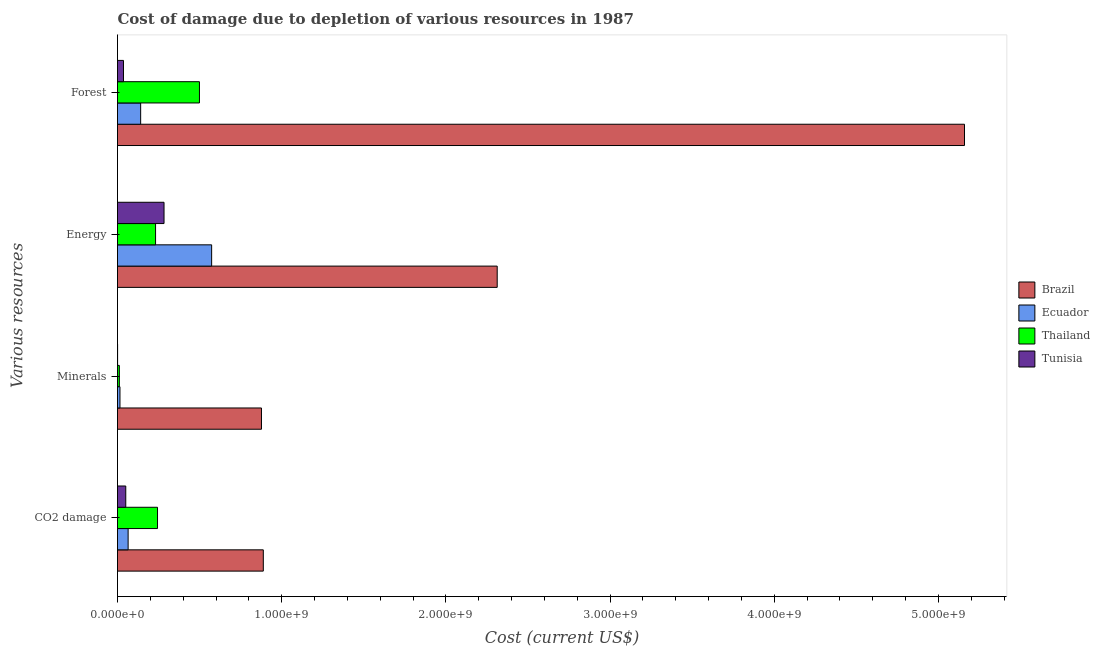How many different coloured bars are there?
Keep it short and to the point. 4. How many groups of bars are there?
Give a very brief answer. 4. Are the number of bars on each tick of the Y-axis equal?
Ensure brevity in your answer.  Yes. What is the label of the 1st group of bars from the top?
Offer a very short reply. Forest. What is the cost of damage due to depletion of forests in Tunisia?
Offer a terse response. 3.64e+07. Across all countries, what is the maximum cost of damage due to depletion of energy?
Provide a short and direct response. 2.31e+09. Across all countries, what is the minimum cost of damage due to depletion of coal?
Offer a terse response. 5.03e+07. In which country was the cost of damage due to depletion of minerals minimum?
Your answer should be very brief. Tunisia. What is the total cost of damage due to depletion of coal in the graph?
Offer a terse response. 1.25e+09. What is the difference between the cost of damage due to depletion of coal in Thailand and that in Ecuador?
Keep it short and to the point. 1.79e+08. What is the difference between the cost of damage due to depletion of forests in Brazil and the cost of damage due to depletion of minerals in Ecuador?
Keep it short and to the point. 5.14e+09. What is the average cost of damage due to depletion of energy per country?
Provide a short and direct response. 8.50e+08. What is the difference between the cost of damage due to depletion of energy and cost of damage due to depletion of forests in Tunisia?
Make the answer very short. 2.47e+08. What is the ratio of the cost of damage due to depletion of coal in Ecuador to that in Thailand?
Give a very brief answer. 0.27. What is the difference between the highest and the second highest cost of damage due to depletion of minerals?
Give a very brief answer. 8.62e+08. What is the difference between the highest and the lowest cost of damage due to depletion of coal?
Your response must be concise. 8.38e+08. Is it the case that in every country, the sum of the cost of damage due to depletion of forests and cost of damage due to depletion of coal is greater than the sum of cost of damage due to depletion of minerals and cost of damage due to depletion of energy?
Ensure brevity in your answer.  Yes. What does the 2nd bar from the top in Forest represents?
Your answer should be very brief. Thailand. What does the 3rd bar from the bottom in CO2 damage represents?
Provide a short and direct response. Thailand. Are all the bars in the graph horizontal?
Offer a terse response. Yes. How many countries are there in the graph?
Keep it short and to the point. 4. Are the values on the major ticks of X-axis written in scientific E-notation?
Offer a very short reply. Yes. What is the title of the graph?
Offer a very short reply. Cost of damage due to depletion of various resources in 1987 . Does "Kazakhstan" appear as one of the legend labels in the graph?
Ensure brevity in your answer.  No. What is the label or title of the X-axis?
Your response must be concise. Cost (current US$). What is the label or title of the Y-axis?
Give a very brief answer. Various resources. What is the Cost (current US$) of Brazil in CO2 damage?
Offer a very short reply. 8.88e+08. What is the Cost (current US$) of Ecuador in CO2 damage?
Give a very brief answer. 6.47e+07. What is the Cost (current US$) in Thailand in CO2 damage?
Ensure brevity in your answer.  2.44e+08. What is the Cost (current US$) in Tunisia in CO2 damage?
Provide a succinct answer. 5.03e+07. What is the Cost (current US$) of Brazil in Minerals?
Make the answer very short. 8.77e+08. What is the Cost (current US$) of Ecuador in Minerals?
Your response must be concise. 1.50e+07. What is the Cost (current US$) of Thailand in Minerals?
Keep it short and to the point. 1.12e+07. What is the Cost (current US$) in Tunisia in Minerals?
Provide a short and direct response. 5.67e+05. What is the Cost (current US$) of Brazil in Energy?
Your answer should be compact. 2.31e+09. What is the Cost (current US$) in Ecuador in Energy?
Ensure brevity in your answer.  5.73e+08. What is the Cost (current US$) of Thailand in Energy?
Keep it short and to the point. 2.32e+08. What is the Cost (current US$) of Tunisia in Energy?
Ensure brevity in your answer.  2.83e+08. What is the Cost (current US$) in Brazil in Forest?
Give a very brief answer. 5.16e+09. What is the Cost (current US$) of Ecuador in Forest?
Provide a succinct answer. 1.41e+08. What is the Cost (current US$) in Thailand in Forest?
Provide a succinct answer. 4.99e+08. What is the Cost (current US$) of Tunisia in Forest?
Your response must be concise. 3.64e+07. Across all Various resources, what is the maximum Cost (current US$) in Brazil?
Keep it short and to the point. 5.16e+09. Across all Various resources, what is the maximum Cost (current US$) in Ecuador?
Provide a succinct answer. 5.73e+08. Across all Various resources, what is the maximum Cost (current US$) in Thailand?
Make the answer very short. 4.99e+08. Across all Various resources, what is the maximum Cost (current US$) in Tunisia?
Provide a succinct answer. 2.83e+08. Across all Various resources, what is the minimum Cost (current US$) of Brazil?
Your answer should be very brief. 8.77e+08. Across all Various resources, what is the minimum Cost (current US$) of Ecuador?
Your answer should be very brief. 1.50e+07. Across all Various resources, what is the minimum Cost (current US$) in Thailand?
Your answer should be very brief. 1.12e+07. Across all Various resources, what is the minimum Cost (current US$) of Tunisia?
Provide a succinct answer. 5.67e+05. What is the total Cost (current US$) in Brazil in the graph?
Your response must be concise. 9.24e+09. What is the total Cost (current US$) of Ecuador in the graph?
Keep it short and to the point. 7.94e+08. What is the total Cost (current US$) in Thailand in the graph?
Keep it short and to the point. 9.86e+08. What is the total Cost (current US$) of Tunisia in the graph?
Your answer should be very brief. 3.71e+08. What is the difference between the Cost (current US$) in Brazil in CO2 damage and that in Minerals?
Your response must be concise. 1.12e+07. What is the difference between the Cost (current US$) in Ecuador in CO2 damage and that in Minerals?
Your answer should be very brief. 4.96e+07. What is the difference between the Cost (current US$) in Thailand in CO2 damage and that in Minerals?
Offer a terse response. 2.33e+08. What is the difference between the Cost (current US$) in Tunisia in CO2 damage and that in Minerals?
Make the answer very short. 4.97e+07. What is the difference between the Cost (current US$) in Brazil in CO2 damage and that in Energy?
Offer a terse response. -1.42e+09. What is the difference between the Cost (current US$) in Ecuador in CO2 damage and that in Energy?
Keep it short and to the point. -5.09e+08. What is the difference between the Cost (current US$) in Thailand in CO2 damage and that in Energy?
Offer a very short reply. 1.18e+07. What is the difference between the Cost (current US$) in Tunisia in CO2 damage and that in Energy?
Give a very brief answer. -2.33e+08. What is the difference between the Cost (current US$) of Brazil in CO2 damage and that in Forest?
Offer a very short reply. -4.27e+09. What is the difference between the Cost (current US$) in Ecuador in CO2 damage and that in Forest?
Provide a short and direct response. -7.63e+07. What is the difference between the Cost (current US$) of Thailand in CO2 damage and that in Forest?
Provide a short and direct response. -2.55e+08. What is the difference between the Cost (current US$) of Tunisia in CO2 damage and that in Forest?
Your answer should be compact. 1.39e+07. What is the difference between the Cost (current US$) of Brazil in Minerals and that in Energy?
Keep it short and to the point. -1.44e+09. What is the difference between the Cost (current US$) of Ecuador in Minerals and that in Energy?
Make the answer very short. -5.58e+08. What is the difference between the Cost (current US$) of Thailand in Minerals and that in Energy?
Ensure brevity in your answer.  -2.21e+08. What is the difference between the Cost (current US$) of Tunisia in Minerals and that in Energy?
Give a very brief answer. -2.83e+08. What is the difference between the Cost (current US$) of Brazil in Minerals and that in Forest?
Provide a succinct answer. -4.28e+09. What is the difference between the Cost (current US$) of Ecuador in Minerals and that in Forest?
Offer a very short reply. -1.26e+08. What is the difference between the Cost (current US$) of Thailand in Minerals and that in Forest?
Offer a terse response. -4.88e+08. What is the difference between the Cost (current US$) in Tunisia in Minerals and that in Forest?
Your answer should be very brief. -3.58e+07. What is the difference between the Cost (current US$) in Brazil in Energy and that in Forest?
Ensure brevity in your answer.  -2.85e+09. What is the difference between the Cost (current US$) of Ecuador in Energy and that in Forest?
Offer a terse response. 4.32e+08. What is the difference between the Cost (current US$) in Thailand in Energy and that in Forest?
Provide a short and direct response. -2.67e+08. What is the difference between the Cost (current US$) of Tunisia in Energy and that in Forest?
Give a very brief answer. 2.47e+08. What is the difference between the Cost (current US$) in Brazil in CO2 damage and the Cost (current US$) in Ecuador in Minerals?
Offer a very short reply. 8.73e+08. What is the difference between the Cost (current US$) in Brazil in CO2 damage and the Cost (current US$) in Thailand in Minerals?
Ensure brevity in your answer.  8.77e+08. What is the difference between the Cost (current US$) of Brazil in CO2 damage and the Cost (current US$) of Tunisia in Minerals?
Offer a terse response. 8.87e+08. What is the difference between the Cost (current US$) of Ecuador in CO2 damage and the Cost (current US$) of Thailand in Minerals?
Provide a succinct answer. 5.35e+07. What is the difference between the Cost (current US$) in Ecuador in CO2 damage and the Cost (current US$) in Tunisia in Minerals?
Give a very brief answer. 6.41e+07. What is the difference between the Cost (current US$) in Thailand in CO2 damage and the Cost (current US$) in Tunisia in Minerals?
Make the answer very short. 2.43e+08. What is the difference between the Cost (current US$) in Brazil in CO2 damage and the Cost (current US$) in Ecuador in Energy?
Your answer should be compact. 3.15e+08. What is the difference between the Cost (current US$) in Brazil in CO2 damage and the Cost (current US$) in Thailand in Energy?
Give a very brief answer. 6.56e+08. What is the difference between the Cost (current US$) in Brazil in CO2 damage and the Cost (current US$) in Tunisia in Energy?
Give a very brief answer. 6.05e+08. What is the difference between the Cost (current US$) in Ecuador in CO2 damage and the Cost (current US$) in Thailand in Energy?
Provide a succinct answer. -1.67e+08. What is the difference between the Cost (current US$) in Ecuador in CO2 damage and the Cost (current US$) in Tunisia in Energy?
Provide a succinct answer. -2.19e+08. What is the difference between the Cost (current US$) of Thailand in CO2 damage and the Cost (current US$) of Tunisia in Energy?
Give a very brief answer. -3.97e+07. What is the difference between the Cost (current US$) in Brazil in CO2 damage and the Cost (current US$) in Ecuador in Forest?
Provide a succinct answer. 7.47e+08. What is the difference between the Cost (current US$) of Brazil in CO2 damage and the Cost (current US$) of Thailand in Forest?
Give a very brief answer. 3.89e+08. What is the difference between the Cost (current US$) of Brazil in CO2 damage and the Cost (current US$) of Tunisia in Forest?
Offer a terse response. 8.52e+08. What is the difference between the Cost (current US$) of Ecuador in CO2 damage and the Cost (current US$) of Thailand in Forest?
Make the answer very short. -4.34e+08. What is the difference between the Cost (current US$) of Ecuador in CO2 damage and the Cost (current US$) of Tunisia in Forest?
Your response must be concise. 2.83e+07. What is the difference between the Cost (current US$) of Thailand in CO2 damage and the Cost (current US$) of Tunisia in Forest?
Make the answer very short. 2.07e+08. What is the difference between the Cost (current US$) of Brazil in Minerals and the Cost (current US$) of Ecuador in Energy?
Provide a succinct answer. 3.03e+08. What is the difference between the Cost (current US$) of Brazil in Minerals and the Cost (current US$) of Thailand in Energy?
Provide a short and direct response. 6.45e+08. What is the difference between the Cost (current US$) of Brazil in Minerals and the Cost (current US$) of Tunisia in Energy?
Your answer should be very brief. 5.93e+08. What is the difference between the Cost (current US$) in Ecuador in Minerals and the Cost (current US$) in Thailand in Energy?
Offer a very short reply. -2.17e+08. What is the difference between the Cost (current US$) in Ecuador in Minerals and the Cost (current US$) in Tunisia in Energy?
Provide a short and direct response. -2.68e+08. What is the difference between the Cost (current US$) of Thailand in Minerals and the Cost (current US$) of Tunisia in Energy?
Your response must be concise. -2.72e+08. What is the difference between the Cost (current US$) of Brazil in Minerals and the Cost (current US$) of Ecuador in Forest?
Make the answer very short. 7.36e+08. What is the difference between the Cost (current US$) of Brazil in Minerals and the Cost (current US$) of Thailand in Forest?
Keep it short and to the point. 3.78e+08. What is the difference between the Cost (current US$) of Brazil in Minerals and the Cost (current US$) of Tunisia in Forest?
Your answer should be very brief. 8.40e+08. What is the difference between the Cost (current US$) of Ecuador in Minerals and the Cost (current US$) of Thailand in Forest?
Your answer should be very brief. -4.84e+08. What is the difference between the Cost (current US$) of Ecuador in Minerals and the Cost (current US$) of Tunisia in Forest?
Offer a very short reply. -2.13e+07. What is the difference between the Cost (current US$) of Thailand in Minerals and the Cost (current US$) of Tunisia in Forest?
Make the answer very short. -2.52e+07. What is the difference between the Cost (current US$) of Brazil in Energy and the Cost (current US$) of Ecuador in Forest?
Give a very brief answer. 2.17e+09. What is the difference between the Cost (current US$) of Brazil in Energy and the Cost (current US$) of Thailand in Forest?
Give a very brief answer. 1.81e+09. What is the difference between the Cost (current US$) of Brazil in Energy and the Cost (current US$) of Tunisia in Forest?
Your answer should be very brief. 2.28e+09. What is the difference between the Cost (current US$) of Ecuador in Energy and the Cost (current US$) of Thailand in Forest?
Ensure brevity in your answer.  7.42e+07. What is the difference between the Cost (current US$) in Ecuador in Energy and the Cost (current US$) in Tunisia in Forest?
Provide a short and direct response. 5.37e+08. What is the difference between the Cost (current US$) in Thailand in Energy and the Cost (current US$) in Tunisia in Forest?
Provide a short and direct response. 1.95e+08. What is the average Cost (current US$) in Brazil per Various resources?
Offer a very short reply. 2.31e+09. What is the average Cost (current US$) in Ecuador per Various resources?
Give a very brief answer. 1.99e+08. What is the average Cost (current US$) in Thailand per Various resources?
Your answer should be compact. 2.46e+08. What is the average Cost (current US$) in Tunisia per Various resources?
Keep it short and to the point. 9.26e+07. What is the difference between the Cost (current US$) in Brazil and Cost (current US$) in Ecuador in CO2 damage?
Give a very brief answer. 8.23e+08. What is the difference between the Cost (current US$) in Brazil and Cost (current US$) in Thailand in CO2 damage?
Keep it short and to the point. 6.44e+08. What is the difference between the Cost (current US$) of Brazil and Cost (current US$) of Tunisia in CO2 damage?
Offer a terse response. 8.38e+08. What is the difference between the Cost (current US$) in Ecuador and Cost (current US$) in Thailand in CO2 damage?
Offer a terse response. -1.79e+08. What is the difference between the Cost (current US$) in Ecuador and Cost (current US$) in Tunisia in CO2 damage?
Make the answer very short. 1.44e+07. What is the difference between the Cost (current US$) of Thailand and Cost (current US$) of Tunisia in CO2 damage?
Offer a very short reply. 1.93e+08. What is the difference between the Cost (current US$) in Brazil and Cost (current US$) in Ecuador in Minerals?
Offer a terse response. 8.62e+08. What is the difference between the Cost (current US$) of Brazil and Cost (current US$) of Thailand in Minerals?
Offer a very short reply. 8.66e+08. What is the difference between the Cost (current US$) of Brazil and Cost (current US$) of Tunisia in Minerals?
Make the answer very short. 8.76e+08. What is the difference between the Cost (current US$) of Ecuador and Cost (current US$) of Thailand in Minerals?
Offer a terse response. 3.88e+06. What is the difference between the Cost (current US$) of Ecuador and Cost (current US$) of Tunisia in Minerals?
Provide a succinct answer. 1.45e+07. What is the difference between the Cost (current US$) of Thailand and Cost (current US$) of Tunisia in Minerals?
Your answer should be compact. 1.06e+07. What is the difference between the Cost (current US$) of Brazil and Cost (current US$) of Ecuador in Energy?
Your answer should be compact. 1.74e+09. What is the difference between the Cost (current US$) of Brazil and Cost (current US$) of Thailand in Energy?
Give a very brief answer. 2.08e+09. What is the difference between the Cost (current US$) in Brazil and Cost (current US$) in Tunisia in Energy?
Your answer should be compact. 2.03e+09. What is the difference between the Cost (current US$) in Ecuador and Cost (current US$) in Thailand in Energy?
Provide a short and direct response. 3.41e+08. What is the difference between the Cost (current US$) in Ecuador and Cost (current US$) in Tunisia in Energy?
Provide a short and direct response. 2.90e+08. What is the difference between the Cost (current US$) in Thailand and Cost (current US$) in Tunisia in Energy?
Provide a short and direct response. -5.15e+07. What is the difference between the Cost (current US$) in Brazil and Cost (current US$) in Ecuador in Forest?
Offer a very short reply. 5.02e+09. What is the difference between the Cost (current US$) of Brazil and Cost (current US$) of Thailand in Forest?
Provide a succinct answer. 4.66e+09. What is the difference between the Cost (current US$) of Brazil and Cost (current US$) of Tunisia in Forest?
Offer a terse response. 5.12e+09. What is the difference between the Cost (current US$) of Ecuador and Cost (current US$) of Thailand in Forest?
Ensure brevity in your answer.  -3.58e+08. What is the difference between the Cost (current US$) of Ecuador and Cost (current US$) of Tunisia in Forest?
Your answer should be very brief. 1.05e+08. What is the difference between the Cost (current US$) in Thailand and Cost (current US$) in Tunisia in Forest?
Offer a very short reply. 4.63e+08. What is the ratio of the Cost (current US$) of Brazil in CO2 damage to that in Minerals?
Provide a short and direct response. 1.01. What is the ratio of the Cost (current US$) in Ecuador in CO2 damage to that in Minerals?
Provide a short and direct response. 4.3. What is the ratio of the Cost (current US$) of Thailand in CO2 damage to that in Minerals?
Offer a very short reply. 21.85. What is the ratio of the Cost (current US$) of Tunisia in CO2 damage to that in Minerals?
Make the answer very short. 88.62. What is the ratio of the Cost (current US$) in Brazil in CO2 damage to that in Energy?
Give a very brief answer. 0.38. What is the ratio of the Cost (current US$) in Ecuador in CO2 damage to that in Energy?
Make the answer very short. 0.11. What is the ratio of the Cost (current US$) of Thailand in CO2 damage to that in Energy?
Make the answer very short. 1.05. What is the ratio of the Cost (current US$) in Tunisia in CO2 damage to that in Energy?
Make the answer very short. 0.18. What is the ratio of the Cost (current US$) of Brazil in CO2 damage to that in Forest?
Provide a succinct answer. 0.17. What is the ratio of the Cost (current US$) in Ecuador in CO2 damage to that in Forest?
Your response must be concise. 0.46. What is the ratio of the Cost (current US$) in Thailand in CO2 damage to that in Forest?
Ensure brevity in your answer.  0.49. What is the ratio of the Cost (current US$) of Tunisia in CO2 damage to that in Forest?
Provide a succinct answer. 1.38. What is the ratio of the Cost (current US$) in Brazil in Minerals to that in Energy?
Your response must be concise. 0.38. What is the ratio of the Cost (current US$) of Ecuador in Minerals to that in Energy?
Offer a terse response. 0.03. What is the ratio of the Cost (current US$) in Thailand in Minerals to that in Energy?
Your answer should be compact. 0.05. What is the ratio of the Cost (current US$) in Tunisia in Minerals to that in Energy?
Your answer should be very brief. 0. What is the ratio of the Cost (current US$) of Brazil in Minerals to that in Forest?
Provide a short and direct response. 0.17. What is the ratio of the Cost (current US$) in Ecuador in Minerals to that in Forest?
Ensure brevity in your answer.  0.11. What is the ratio of the Cost (current US$) in Thailand in Minerals to that in Forest?
Provide a short and direct response. 0.02. What is the ratio of the Cost (current US$) of Tunisia in Minerals to that in Forest?
Provide a succinct answer. 0.02. What is the ratio of the Cost (current US$) of Brazil in Energy to that in Forest?
Provide a succinct answer. 0.45. What is the ratio of the Cost (current US$) of Ecuador in Energy to that in Forest?
Your answer should be compact. 4.07. What is the ratio of the Cost (current US$) of Thailand in Energy to that in Forest?
Offer a very short reply. 0.46. What is the ratio of the Cost (current US$) of Tunisia in Energy to that in Forest?
Provide a short and direct response. 7.79. What is the difference between the highest and the second highest Cost (current US$) in Brazil?
Offer a very short reply. 2.85e+09. What is the difference between the highest and the second highest Cost (current US$) in Ecuador?
Provide a succinct answer. 4.32e+08. What is the difference between the highest and the second highest Cost (current US$) of Thailand?
Provide a succinct answer. 2.55e+08. What is the difference between the highest and the second highest Cost (current US$) in Tunisia?
Offer a terse response. 2.33e+08. What is the difference between the highest and the lowest Cost (current US$) of Brazil?
Offer a very short reply. 4.28e+09. What is the difference between the highest and the lowest Cost (current US$) in Ecuador?
Offer a terse response. 5.58e+08. What is the difference between the highest and the lowest Cost (current US$) in Thailand?
Offer a very short reply. 4.88e+08. What is the difference between the highest and the lowest Cost (current US$) in Tunisia?
Provide a succinct answer. 2.83e+08. 